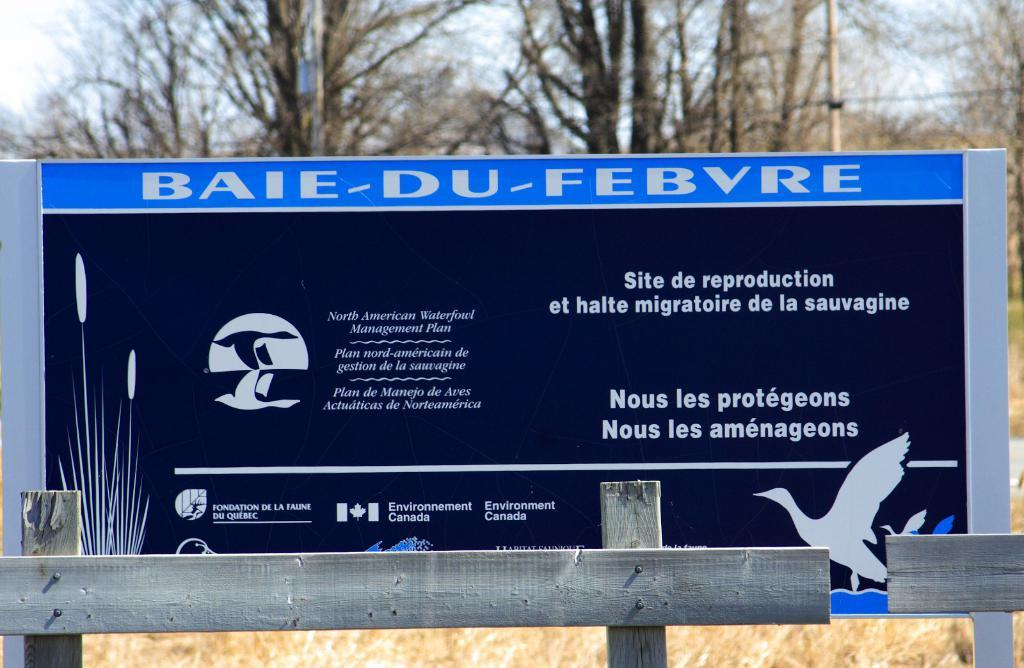<image>
Create a compact narrative representing the image presented. An outdoor black and blue billboard with Baie-Du-Febvre on it. 